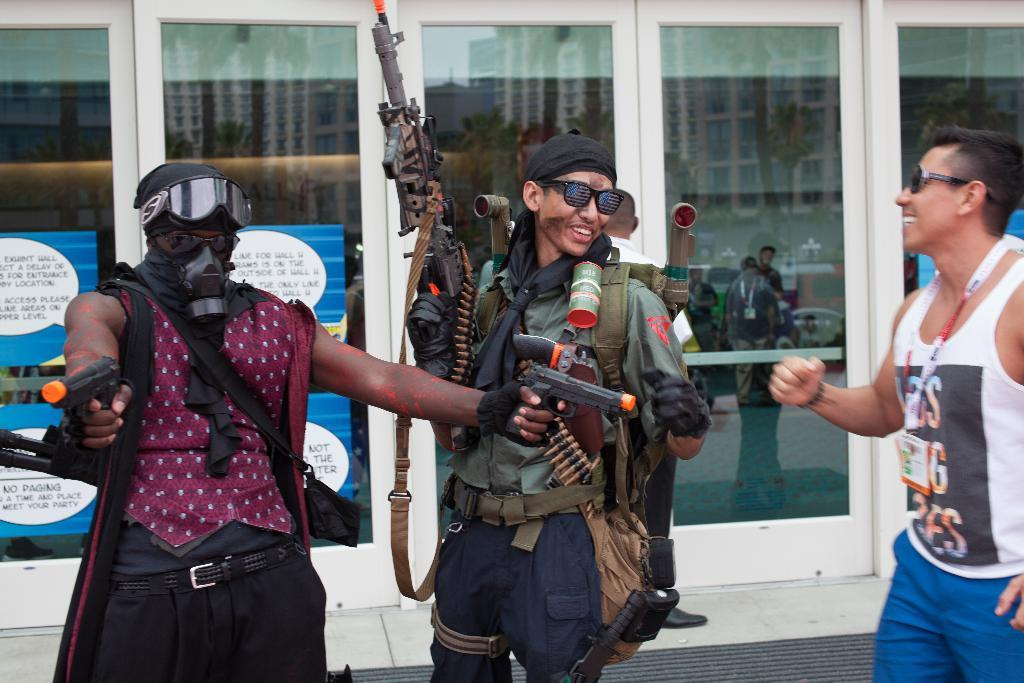How many people are present in the image? There are three people standing in the image. What can be observed about the people's eyesight? Three of the people are wearing spectacles. What objects are being held by some of the people? Two people are holding guns. Can you identify any form of identification on one of the individuals? One person is wearing an ID card. What type of flag is being waved by the person in the image? There is no flag present in the image. What mode of transport is being used by the people in the image? The image does not show any form of transport being used by the people. 